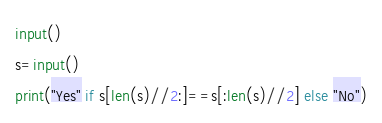Convert code to text. <code><loc_0><loc_0><loc_500><loc_500><_Python_>input()
s=input()
print("Yes" if s[len(s)//2:]==s[:len(s)//2] else "No")
</code> 